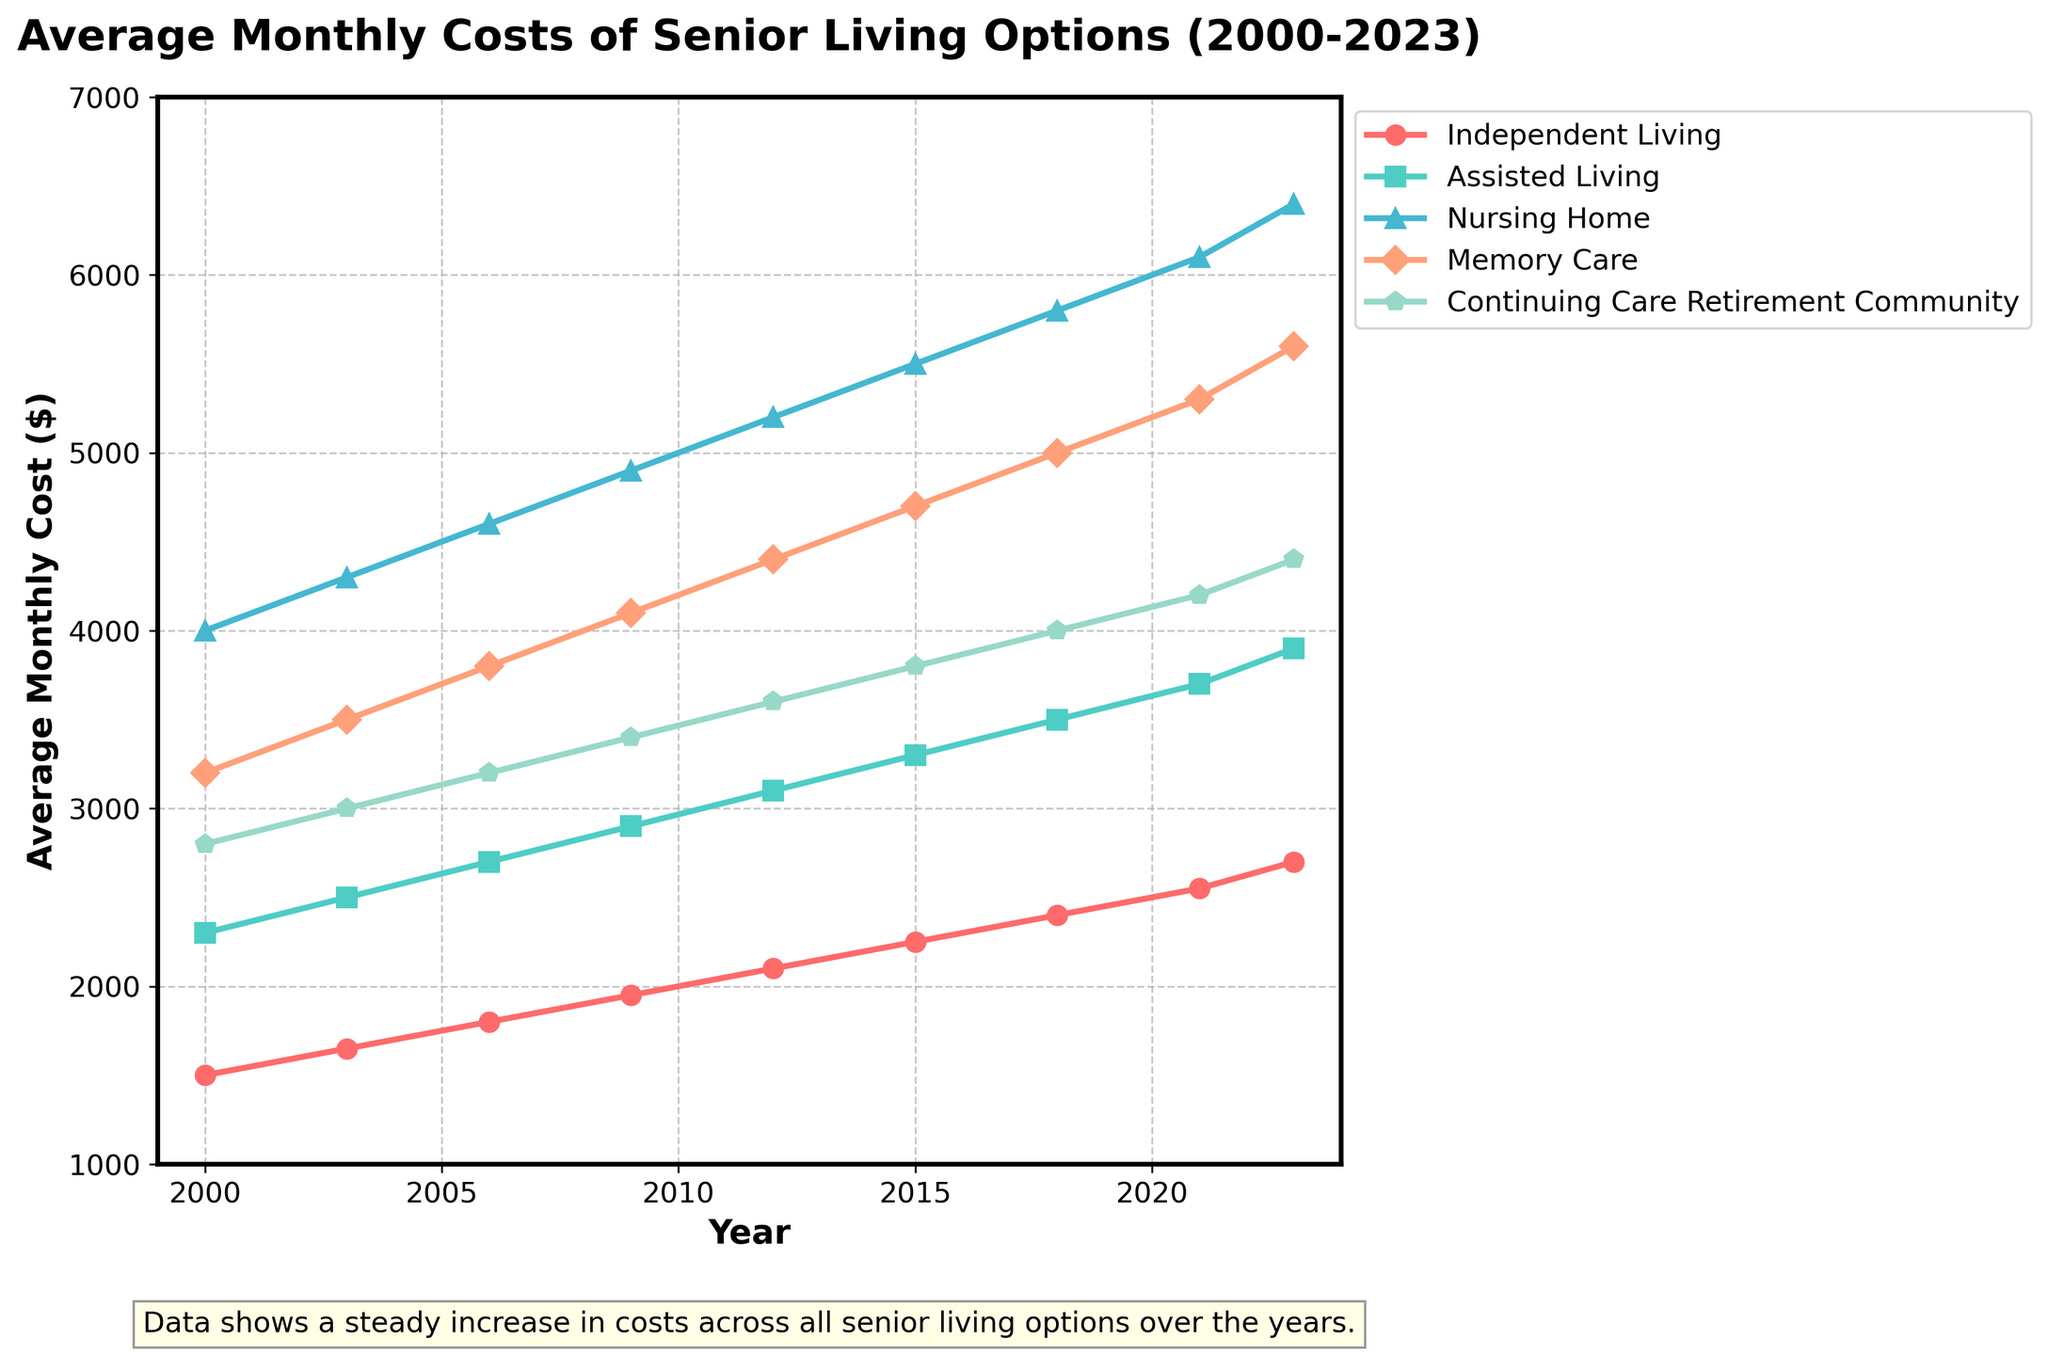what is the average cost of Independent Living and Assisted Living in 2023? To find the average cost, we first add the costs of Independent Living and Assisted Living in 2023, which are $2700 and $3900 respectively. Then, we divide the sum by 2: (2700 + 3900)/2 = 6600/2 = 3300
Answer: 3300 Which senior living option had the highest monthly cost in the year 2006? By observing the data for the year 2006, the highest monthly cost is for Nursing Home at $4600. Thus, Nursing Home had the highest cost in 2006
Answer: Nursing Home Compare the increase in monthly costs for Memory Care between 2000 and 2023. The cost of Memory Care in 2000 was $3200, and in 2023, it was $5600. The increase in costs can be calculated by subtracting the cost in 2000 from the cost in 2023: 5600 - 3200 = 2400. So, the increase is $2400
Answer: 2400 Which living option has shown the least increase in costs between 2000 and 2023? To determine the least increase, we calculate the difference in costs between 2000 and 2023 for each category. The differences are: Independent Living: (2700-1500)=1200, Assisted Living: (3900-2300)=1600, Nursing Home: (6400-4000)=2400, Memory Care: (5600-3200)=2400, Continuing Care Retirement Community: (4400-2800)=1600. Independent Living shows the least increase, with 1200
Answer: Independent Living What was the difference in the monthly cost between Independent Living and Nursing Home in 2021? In 2021, the cost of Independent Living was $2550, and the cost of Nursing Home was $6100. The difference between these costs is 6100 - 2550 = 3550
Answer: 3550 Which two senior living options had the largest gap in costs in 2009? By comparing the costs in 2009, we see that the largest gap is between Nursing Home ($4900) and Independent Living ($1950). The gap is 4900 - 1950 = 2950
Answer: Nursing Home and Independent Living Visually, which senior living option has the steepest upward trend in costs from 2000 to 2023? By visually analyzing the plot, the Nursing Home category shows the steepest upward trend, as its costs increase the most dramatically over the years
Answer: Nursing Home What is the combined cost of Assisted Living and Continuing Care Retirement Community in 2015? Combining the costs of Assisted Living ($3300) and Continuing Care Retirement Community ($3800) in 2015, we get: 3300 + 3800 = 7100
Answer: 7100 Which senior living option had just about the same costs in 2012 and 2023? In 2012, the cost for Continuing Care Retirement Community is $3600, and in 2023 it is $4400. Thus, Continuing Care Retirement Community had about the same comparison increase in costs between 2012 and other years where other categories increased more
Answer: Continuing Care Retirement Community 